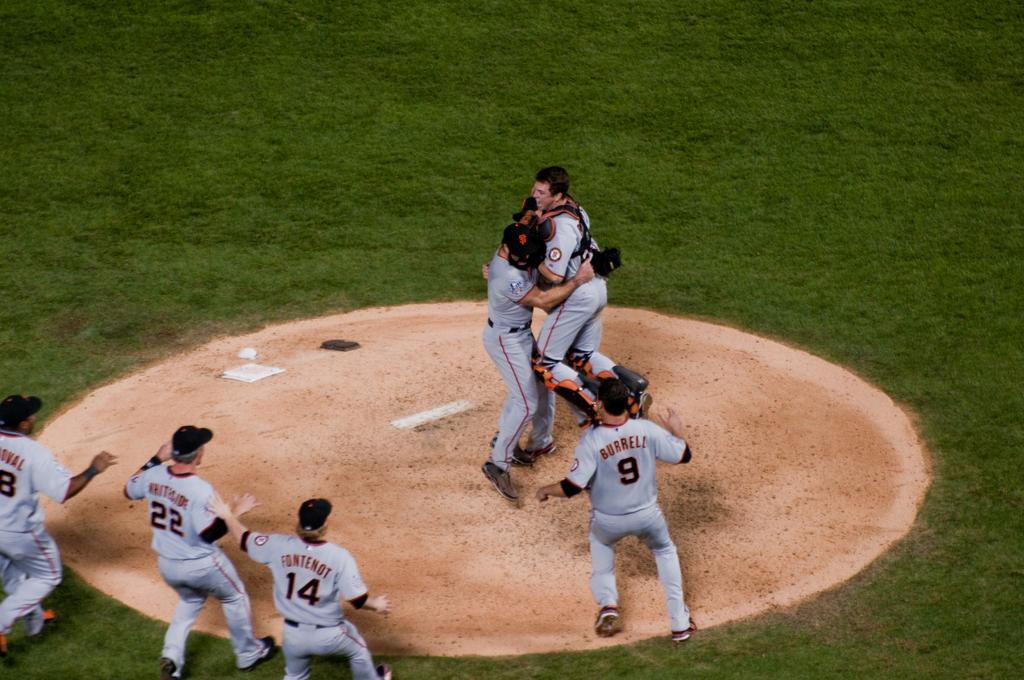<image>
Write a terse but informative summary of the picture. A baseball team is hugging the pitcher and a player's jersey says Burreli. 